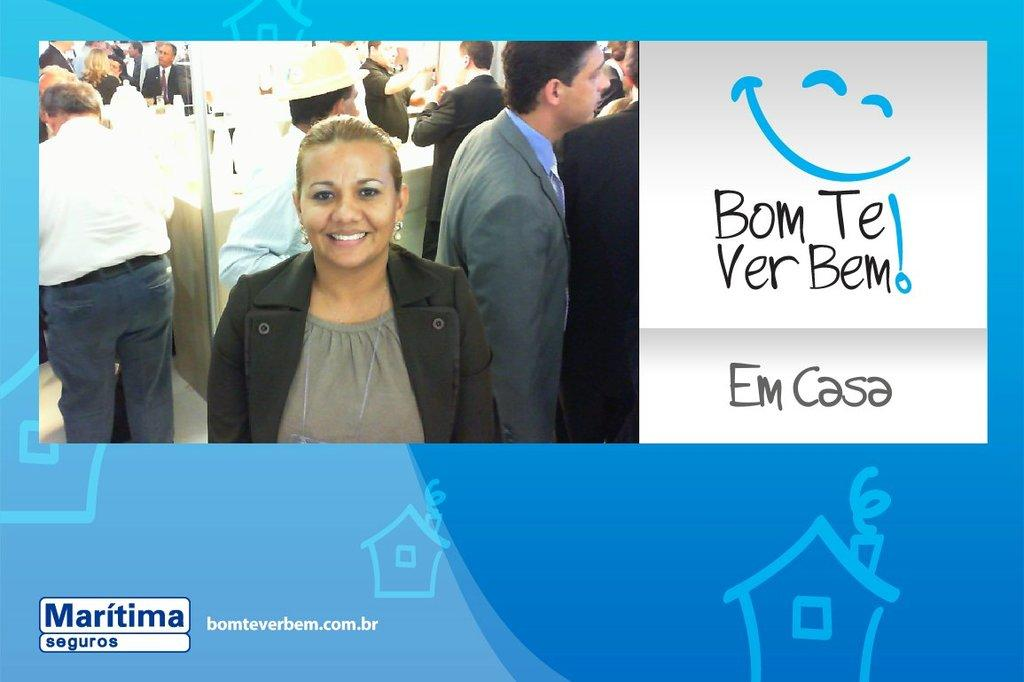What is the main subject of the image? The main subject of the image is a group of people. How can you describe the attire of the people in the image? The people in the image are wearing different color dresses. Can you identify any accessories worn by the people in the image? One person is wearing a hat. What else can be seen in the image besides the people? There is text visible in the image. What type of development can be seen in the background of the image? There is no development visible in the background of the image; it only features a group of people wearing different color dresses, one person wearing a hat, and text. Can you tell me how many balloons are being held by the people in the image? There are no balloons present in the image; the people are not holding any. 